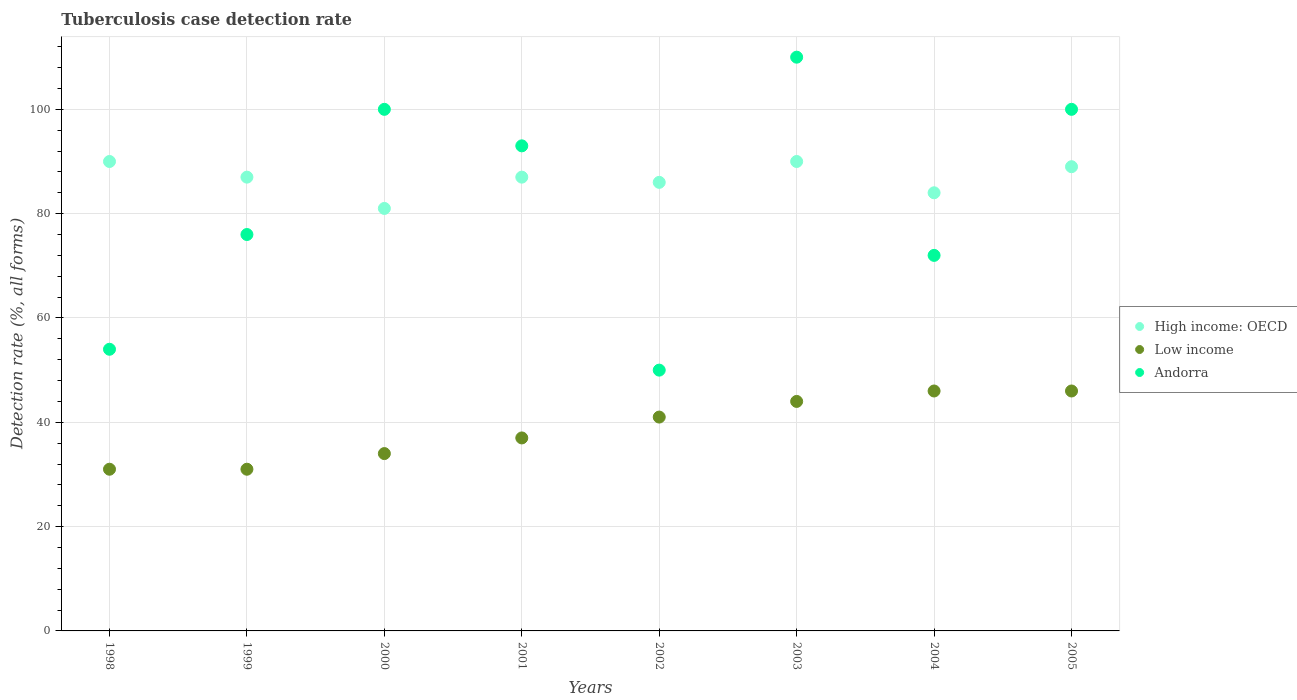How many different coloured dotlines are there?
Provide a succinct answer. 3. What is the tuberculosis case detection rate in in Low income in 2002?
Your response must be concise. 41. Across all years, what is the maximum tuberculosis case detection rate in in Low income?
Your response must be concise. 46. Across all years, what is the minimum tuberculosis case detection rate in in High income: OECD?
Offer a very short reply. 81. In which year was the tuberculosis case detection rate in in Andorra minimum?
Ensure brevity in your answer.  2002. What is the total tuberculosis case detection rate in in High income: OECD in the graph?
Make the answer very short. 694. What is the difference between the tuberculosis case detection rate in in Low income in 2002 and that in 2003?
Make the answer very short. -3. What is the difference between the tuberculosis case detection rate in in Low income in 2003 and the tuberculosis case detection rate in in High income: OECD in 2005?
Your answer should be very brief. -45. What is the average tuberculosis case detection rate in in Low income per year?
Make the answer very short. 38.75. In the year 2002, what is the difference between the tuberculosis case detection rate in in Andorra and tuberculosis case detection rate in in High income: OECD?
Ensure brevity in your answer.  -36. What is the ratio of the tuberculosis case detection rate in in Low income in 2002 to that in 2003?
Your answer should be very brief. 0.93. Is the tuberculosis case detection rate in in Andorra in 2001 less than that in 2005?
Ensure brevity in your answer.  Yes. Is the difference between the tuberculosis case detection rate in in Andorra in 1998 and 2002 greater than the difference between the tuberculosis case detection rate in in High income: OECD in 1998 and 2002?
Give a very brief answer. No. What is the difference between the highest and the second highest tuberculosis case detection rate in in Andorra?
Provide a short and direct response. 10. What is the difference between the highest and the lowest tuberculosis case detection rate in in High income: OECD?
Your answer should be very brief. 9. In how many years, is the tuberculosis case detection rate in in High income: OECD greater than the average tuberculosis case detection rate in in High income: OECD taken over all years?
Offer a very short reply. 5. Does the tuberculosis case detection rate in in High income: OECD monotonically increase over the years?
Ensure brevity in your answer.  No. Is the tuberculosis case detection rate in in Low income strictly greater than the tuberculosis case detection rate in in High income: OECD over the years?
Provide a short and direct response. No. How are the legend labels stacked?
Your answer should be very brief. Vertical. What is the title of the graph?
Provide a short and direct response. Tuberculosis case detection rate. What is the label or title of the X-axis?
Provide a short and direct response. Years. What is the label or title of the Y-axis?
Give a very brief answer. Detection rate (%, all forms). What is the Detection rate (%, all forms) of Andorra in 1998?
Your response must be concise. 54. What is the Detection rate (%, all forms) in High income: OECD in 1999?
Provide a short and direct response. 87. What is the Detection rate (%, all forms) in Low income in 1999?
Provide a succinct answer. 31. What is the Detection rate (%, all forms) of Andorra in 1999?
Your answer should be compact. 76. What is the Detection rate (%, all forms) of Low income in 2000?
Provide a succinct answer. 34. What is the Detection rate (%, all forms) of Andorra in 2000?
Give a very brief answer. 100. What is the Detection rate (%, all forms) in High income: OECD in 2001?
Provide a succinct answer. 87. What is the Detection rate (%, all forms) in Low income in 2001?
Your answer should be compact. 37. What is the Detection rate (%, all forms) in Andorra in 2001?
Offer a very short reply. 93. What is the Detection rate (%, all forms) in Low income in 2002?
Provide a succinct answer. 41. What is the Detection rate (%, all forms) in Low income in 2003?
Ensure brevity in your answer.  44. What is the Detection rate (%, all forms) of Andorra in 2003?
Ensure brevity in your answer.  110. What is the Detection rate (%, all forms) in High income: OECD in 2004?
Ensure brevity in your answer.  84. What is the Detection rate (%, all forms) of Low income in 2004?
Provide a short and direct response. 46. What is the Detection rate (%, all forms) of Andorra in 2004?
Make the answer very short. 72. What is the Detection rate (%, all forms) in High income: OECD in 2005?
Your response must be concise. 89. Across all years, what is the maximum Detection rate (%, all forms) in Low income?
Your response must be concise. 46. Across all years, what is the maximum Detection rate (%, all forms) in Andorra?
Make the answer very short. 110. Across all years, what is the minimum Detection rate (%, all forms) of Andorra?
Provide a succinct answer. 50. What is the total Detection rate (%, all forms) of High income: OECD in the graph?
Your answer should be very brief. 694. What is the total Detection rate (%, all forms) in Low income in the graph?
Make the answer very short. 310. What is the total Detection rate (%, all forms) of Andorra in the graph?
Your answer should be compact. 655. What is the difference between the Detection rate (%, all forms) of High income: OECD in 1998 and that in 1999?
Provide a short and direct response. 3. What is the difference between the Detection rate (%, all forms) of Low income in 1998 and that in 1999?
Offer a terse response. 0. What is the difference between the Detection rate (%, all forms) of Andorra in 1998 and that in 1999?
Make the answer very short. -22. What is the difference between the Detection rate (%, all forms) in High income: OECD in 1998 and that in 2000?
Your answer should be compact. 9. What is the difference between the Detection rate (%, all forms) of Andorra in 1998 and that in 2000?
Make the answer very short. -46. What is the difference between the Detection rate (%, all forms) in Low income in 1998 and that in 2001?
Provide a short and direct response. -6. What is the difference between the Detection rate (%, all forms) in Andorra in 1998 and that in 2001?
Make the answer very short. -39. What is the difference between the Detection rate (%, all forms) in Andorra in 1998 and that in 2002?
Your answer should be very brief. 4. What is the difference between the Detection rate (%, all forms) of High income: OECD in 1998 and that in 2003?
Give a very brief answer. 0. What is the difference between the Detection rate (%, all forms) in Andorra in 1998 and that in 2003?
Make the answer very short. -56. What is the difference between the Detection rate (%, all forms) in Low income in 1998 and that in 2004?
Ensure brevity in your answer.  -15. What is the difference between the Detection rate (%, all forms) of High income: OECD in 1998 and that in 2005?
Provide a succinct answer. 1. What is the difference between the Detection rate (%, all forms) of Andorra in 1998 and that in 2005?
Offer a very short reply. -46. What is the difference between the Detection rate (%, all forms) of Low income in 1999 and that in 2000?
Your response must be concise. -3. What is the difference between the Detection rate (%, all forms) in Andorra in 1999 and that in 2000?
Offer a terse response. -24. What is the difference between the Detection rate (%, all forms) of High income: OECD in 1999 and that in 2001?
Make the answer very short. 0. What is the difference between the Detection rate (%, all forms) in High income: OECD in 1999 and that in 2002?
Make the answer very short. 1. What is the difference between the Detection rate (%, all forms) of Low income in 1999 and that in 2002?
Provide a succinct answer. -10. What is the difference between the Detection rate (%, all forms) in High income: OECD in 1999 and that in 2003?
Provide a succinct answer. -3. What is the difference between the Detection rate (%, all forms) of Andorra in 1999 and that in 2003?
Ensure brevity in your answer.  -34. What is the difference between the Detection rate (%, all forms) of Andorra in 1999 and that in 2004?
Provide a short and direct response. 4. What is the difference between the Detection rate (%, all forms) of Low income in 1999 and that in 2005?
Your answer should be compact. -15. What is the difference between the Detection rate (%, all forms) in Andorra in 1999 and that in 2005?
Offer a terse response. -24. What is the difference between the Detection rate (%, all forms) of Low income in 2000 and that in 2001?
Provide a succinct answer. -3. What is the difference between the Detection rate (%, all forms) of Low income in 2000 and that in 2002?
Your response must be concise. -7. What is the difference between the Detection rate (%, all forms) of Andorra in 2000 and that in 2002?
Make the answer very short. 50. What is the difference between the Detection rate (%, all forms) of High income: OECD in 2000 and that in 2004?
Ensure brevity in your answer.  -3. What is the difference between the Detection rate (%, all forms) of Low income in 2000 and that in 2004?
Your answer should be compact. -12. What is the difference between the Detection rate (%, all forms) in High income: OECD in 2000 and that in 2005?
Your response must be concise. -8. What is the difference between the Detection rate (%, all forms) in Low income in 2001 and that in 2002?
Provide a short and direct response. -4. What is the difference between the Detection rate (%, all forms) of High income: OECD in 2001 and that in 2003?
Your response must be concise. -3. What is the difference between the Detection rate (%, all forms) of High income: OECD in 2001 and that in 2004?
Your answer should be very brief. 3. What is the difference between the Detection rate (%, all forms) of Low income in 2001 and that in 2004?
Provide a short and direct response. -9. What is the difference between the Detection rate (%, all forms) in Low income in 2001 and that in 2005?
Make the answer very short. -9. What is the difference between the Detection rate (%, all forms) in High income: OECD in 2002 and that in 2003?
Make the answer very short. -4. What is the difference between the Detection rate (%, all forms) in Low income in 2002 and that in 2003?
Offer a very short reply. -3. What is the difference between the Detection rate (%, all forms) in Andorra in 2002 and that in 2003?
Make the answer very short. -60. What is the difference between the Detection rate (%, all forms) in Low income in 2002 and that in 2004?
Keep it short and to the point. -5. What is the difference between the Detection rate (%, all forms) of Low income in 2002 and that in 2005?
Give a very brief answer. -5. What is the difference between the Detection rate (%, all forms) of High income: OECD in 2003 and that in 2004?
Give a very brief answer. 6. What is the difference between the Detection rate (%, all forms) in Low income in 2003 and that in 2004?
Your response must be concise. -2. What is the difference between the Detection rate (%, all forms) in Andorra in 2003 and that in 2004?
Make the answer very short. 38. What is the difference between the Detection rate (%, all forms) of High income: OECD in 2003 and that in 2005?
Your answer should be compact. 1. What is the difference between the Detection rate (%, all forms) in Low income in 2003 and that in 2005?
Make the answer very short. -2. What is the difference between the Detection rate (%, all forms) in Andorra in 2003 and that in 2005?
Your response must be concise. 10. What is the difference between the Detection rate (%, all forms) of Low income in 2004 and that in 2005?
Give a very brief answer. 0. What is the difference between the Detection rate (%, all forms) in Andorra in 2004 and that in 2005?
Give a very brief answer. -28. What is the difference between the Detection rate (%, all forms) of Low income in 1998 and the Detection rate (%, all forms) of Andorra in 1999?
Give a very brief answer. -45. What is the difference between the Detection rate (%, all forms) of High income: OECD in 1998 and the Detection rate (%, all forms) of Low income in 2000?
Keep it short and to the point. 56. What is the difference between the Detection rate (%, all forms) of High income: OECD in 1998 and the Detection rate (%, all forms) of Andorra in 2000?
Ensure brevity in your answer.  -10. What is the difference between the Detection rate (%, all forms) in Low income in 1998 and the Detection rate (%, all forms) in Andorra in 2000?
Your response must be concise. -69. What is the difference between the Detection rate (%, all forms) in High income: OECD in 1998 and the Detection rate (%, all forms) in Low income in 2001?
Offer a very short reply. 53. What is the difference between the Detection rate (%, all forms) in Low income in 1998 and the Detection rate (%, all forms) in Andorra in 2001?
Your answer should be compact. -62. What is the difference between the Detection rate (%, all forms) in High income: OECD in 1998 and the Detection rate (%, all forms) in Low income in 2002?
Keep it short and to the point. 49. What is the difference between the Detection rate (%, all forms) in High income: OECD in 1998 and the Detection rate (%, all forms) in Andorra in 2002?
Your response must be concise. 40. What is the difference between the Detection rate (%, all forms) in Low income in 1998 and the Detection rate (%, all forms) in Andorra in 2002?
Offer a very short reply. -19. What is the difference between the Detection rate (%, all forms) in High income: OECD in 1998 and the Detection rate (%, all forms) in Low income in 2003?
Ensure brevity in your answer.  46. What is the difference between the Detection rate (%, all forms) in High income: OECD in 1998 and the Detection rate (%, all forms) in Andorra in 2003?
Provide a short and direct response. -20. What is the difference between the Detection rate (%, all forms) in Low income in 1998 and the Detection rate (%, all forms) in Andorra in 2003?
Give a very brief answer. -79. What is the difference between the Detection rate (%, all forms) of Low income in 1998 and the Detection rate (%, all forms) of Andorra in 2004?
Offer a very short reply. -41. What is the difference between the Detection rate (%, all forms) in Low income in 1998 and the Detection rate (%, all forms) in Andorra in 2005?
Offer a terse response. -69. What is the difference between the Detection rate (%, all forms) in High income: OECD in 1999 and the Detection rate (%, all forms) in Andorra in 2000?
Make the answer very short. -13. What is the difference between the Detection rate (%, all forms) in Low income in 1999 and the Detection rate (%, all forms) in Andorra in 2000?
Keep it short and to the point. -69. What is the difference between the Detection rate (%, all forms) of Low income in 1999 and the Detection rate (%, all forms) of Andorra in 2001?
Your answer should be compact. -62. What is the difference between the Detection rate (%, all forms) of High income: OECD in 1999 and the Detection rate (%, all forms) of Low income in 2002?
Provide a short and direct response. 46. What is the difference between the Detection rate (%, all forms) of High income: OECD in 1999 and the Detection rate (%, all forms) of Andorra in 2002?
Offer a terse response. 37. What is the difference between the Detection rate (%, all forms) in High income: OECD in 1999 and the Detection rate (%, all forms) in Low income in 2003?
Your response must be concise. 43. What is the difference between the Detection rate (%, all forms) of High income: OECD in 1999 and the Detection rate (%, all forms) of Andorra in 2003?
Make the answer very short. -23. What is the difference between the Detection rate (%, all forms) in Low income in 1999 and the Detection rate (%, all forms) in Andorra in 2003?
Your answer should be very brief. -79. What is the difference between the Detection rate (%, all forms) of High income: OECD in 1999 and the Detection rate (%, all forms) of Low income in 2004?
Keep it short and to the point. 41. What is the difference between the Detection rate (%, all forms) in High income: OECD in 1999 and the Detection rate (%, all forms) in Andorra in 2004?
Keep it short and to the point. 15. What is the difference between the Detection rate (%, all forms) in Low income in 1999 and the Detection rate (%, all forms) in Andorra in 2004?
Keep it short and to the point. -41. What is the difference between the Detection rate (%, all forms) of High income: OECD in 1999 and the Detection rate (%, all forms) of Low income in 2005?
Your response must be concise. 41. What is the difference between the Detection rate (%, all forms) in High income: OECD in 1999 and the Detection rate (%, all forms) in Andorra in 2005?
Ensure brevity in your answer.  -13. What is the difference between the Detection rate (%, all forms) of Low income in 1999 and the Detection rate (%, all forms) of Andorra in 2005?
Offer a very short reply. -69. What is the difference between the Detection rate (%, all forms) in High income: OECD in 2000 and the Detection rate (%, all forms) in Andorra in 2001?
Provide a short and direct response. -12. What is the difference between the Detection rate (%, all forms) of Low income in 2000 and the Detection rate (%, all forms) of Andorra in 2001?
Keep it short and to the point. -59. What is the difference between the Detection rate (%, all forms) of High income: OECD in 2000 and the Detection rate (%, all forms) of Andorra in 2002?
Keep it short and to the point. 31. What is the difference between the Detection rate (%, all forms) in Low income in 2000 and the Detection rate (%, all forms) in Andorra in 2002?
Provide a short and direct response. -16. What is the difference between the Detection rate (%, all forms) of Low income in 2000 and the Detection rate (%, all forms) of Andorra in 2003?
Offer a terse response. -76. What is the difference between the Detection rate (%, all forms) of Low income in 2000 and the Detection rate (%, all forms) of Andorra in 2004?
Keep it short and to the point. -38. What is the difference between the Detection rate (%, all forms) of High income: OECD in 2000 and the Detection rate (%, all forms) of Andorra in 2005?
Ensure brevity in your answer.  -19. What is the difference between the Detection rate (%, all forms) in Low income in 2000 and the Detection rate (%, all forms) in Andorra in 2005?
Provide a succinct answer. -66. What is the difference between the Detection rate (%, all forms) in High income: OECD in 2001 and the Detection rate (%, all forms) in Andorra in 2002?
Ensure brevity in your answer.  37. What is the difference between the Detection rate (%, all forms) of Low income in 2001 and the Detection rate (%, all forms) of Andorra in 2002?
Your response must be concise. -13. What is the difference between the Detection rate (%, all forms) in High income: OECD in 2001 and the Detection rate (%, all forms) in Low income in 2003?
Your answer should be compact. 43. What is the difference between the Detection rate (%, all forms) in High income: OECD in 2001 and the Detection rate (%, all forms) in Andorra in 2003?
Give a very brief answer. -23. What is the difference between the Detection rate (%, all forms) in Low income in 2001 and the Detection rate (%, all forms) in Andorra in 2003?
Make the answer very short. -73. What is the difference between the Detection rate (%, all forms) of High income: OECD in 2001 and the Detection rate (%, all forms) of Andorra in 2004?
Your response must be concise. 15. What is the difference between the Detection rate (%, all forms) in Low income in 2001 and the Detection rate (%, all forms) in Andorra in 2004?
Keep it short and to the point. -35. What is the difference between the Detection rate (%, all forms) in High income: OECD in 2001 and the Detection rate (%, all forms) in Low income in 2005?
Give a very brief answer. 41. What is the difference between the Detection rate (%, all forms) of Low income in 2001 and the Detection rate (%, all forms) of Andorra in 2005?
Offer a terse response. -63. What is the difference between the Detection rate (%, all forms) of High income: OECD in 2002 and the Detection rate (%, all forms) of Low income in 2003?
Your answer should be compact. 42. What is the difference between the Detection rate (%, all forms) of High income: OECD in 2002 and the Detection rate (%, all forms) of Andorra in 2003?
Your response must be concise. -24. What is the difference between the Detection rate (%, all forms) of Low income in 2002 and the Detection rate (%, all forms) of Andorra in 2003?
Offer a terse response. -69. What is the difference between the Detection rate (%, all forms) in High income: OECD in 2002 and the Detection rate (%, all forms) in Andorra in 2004?
Offer a terse response. 14. What is the difference between the Detection rate (%, all forms) of Low income in 2002 and the Detection rate (%, all forms) of Andorra in 2004?
Provide a succinct answer. -31. What is the difference between the Detection rate (%, all forms) in High income: OECD in 2002 and the Detection rate (%, all forms) in Low income in 2005?
Offer a terse response. 40. What is the difference between the Detection rate (%, all forms) of Low income in 2002 and the Detection rate (%, all forms) of Andorra in 2005?
Provide a short and direct response. -59. What is the difference between the Detection rate (%, all forms) in High income: OECD in 2003 and the Detection rate (%, all forms) in Low income in 2004?
Provide a succinct answer. 44. What is the difference between the Detection rate (%, all forms) in Low income in 2003 and the Detection rate (%, all forms) in Andorra in 2005?
Keep it short and to the point. -56. What is the difference between the Detection rate (%, all forms) in High income: OECD in 2004 and the Detection rate (%, all forms) in Low income in 2005?
Make the answer very short. 38. What is the difference between the Detection rate (%, all forms) of High income: OECD in 2004 and the Detection rate (%, all forms) of Andorra in 2005?
Offer a very short reply. -16. What is the difference between the Detection rate (%, all forms) in Low income in 2004 and the Detection rate (%, all forms) in Andorra in 2005?
Your response must be concise. -54. What is the average Detection rate (%, all forms) in High income: OECD per year?
Your response must be concise. 86.75. What is the average Detection rate (%, all forms) in Low income per year?
Your response must be concise. 38.75. What is the average Detection rate (%, all forms) of Andorra per year?
Your answer should be compact. 81.88. In the year 1998, what is the difference between the Detection rate (%, all forms) of High income: OECD and Detection rate (%, all forms) of Low income?
Ensure brevity in your answer.  59. In the year 1998, what is the difference between the Detection rate (%, all forms) of Low income and Detection rate (%, all forms) of Andorra?
Provide a short and direct response. -23. In the year 1999, what is the difference between the Detection rate (%, all forms) of Low income and Detection rate (%, all forms) of Andorra?
Your answer should be compact. -45. In the year 2000, what is the difference between the Detection rate (%, all forms) of High income: OECD and Detection rate (%, all forms) of Andorra?
Offer a terse response. -19. In the year 2000, what is the difference between the Detection rate (%, all forms) in Low income and Detection rate (%, all forms) in Andorra?
Provide a short and direct response. -66. In the year 2001, what is the difference between the Detection rate (%, all forms) in High income: OECD and Detection rate (%, all forms) in Low income?
Your answer should be very brief. 50. In the year 2001, what is the difference between the Detection rate (%, all forms) in Low income and Detection rate (%, all forms) in Andorra?
Provide a short and direct response. -56. In the year 2002, what is the difference between the Detection rate (%, all forms) in High income: OECD and Detection rate (%, all forms) in Andorra?
Keep it short and to the point. 36. In the year 2002, what is the difference between the Detection rate (%, all forms) of Low income and Detection rate (%, all forms) of Andorra?
Keep it short and to the point. -9. In the year 2003, what is the difference between the Detection rate (%, all forms) of High income: OECD and Detection rate (%, all forms) of Andorra?
Your response must be concise. -20. In the year 2003, what is the difference between the Detection rate (%, all forms) in Low income and Detection rate (%, all forms) in Andorra?
Provide a succinct answer. -66. In the year 2004, what is the difference between the Detection rate (%, all forms) of Low income and Detection rate (%, all forms) of Andorra?
Keep it short and to the point. -26. In the year 2005, what is the difference between the Detection rate (%, all forms) in High income: OECD and Detection rate (%, all forms) in Andorra?
Give a very brief answer. -11. In the year 2005, what is the difference between the Detection rate (%, all forms) in Low income and Detection rate (%, all forms) in Andorra?
Give a very brief answer. -54. What is the ratio of the Detection rate (%, all forms) in High income: OECD in 1998 to that in 1999?
Provide a short and direct response. 1.03. What is the ratio of the Detection rate (%, all forms) in Andorra in 1998 to that in 1999?
Keep it short and to the point. 0.71. What is the ratio of the Detection rate (%, all forms) in High income: OECD in 1998 to that in 2000?
Your answer should be compact. 1.11. What is the ratio of the Detection rate (%, all forms) in Low income in 1998 to that in 2000?
Ensure brevity in your answer.  0.91. What is the ratio of the Detection rate (%, all forms) of Andorra in 1998 to that in 2000?
Give a very brief answer. 0.54. What is the ratio of the Detection rate (%, all forms) in High income: OECD in 1998 to that in 2001?
Make the answer very short. 1.03. What is the ratio of the Detection rate (%, all forms) in Low income in 1998 to that in 2001?
Keep it short and to the point. 0.84. What is the ratio of the Detection rate (%, all forms) in Andorra in 1998 to that in 2001?
Your answer should be compact. 0.58. What is the ratio of the Detection rate (%, all forms) in High income: OECD in 1998 to that in 2002?
Provide a short and direct response. 1.05. What is the ratio of the Detection rate (%, all forms) in Low income in 1998 to that in 2002?
Your answer should be very brief. 0.76. What is the ratio of the Detection rate (%, all forms) of High income: OECD in 1998 to that in 2003?
Offer a very short reply. 1. What is the ratio of the Detection rate (%, all forms) of Low income in 1998 to that in 2003?
Your response must be concise. 0.7. What is the ratio of the Detection rate (%, all forms) in Andorra in 1998 to that in 2003?
Your answer should be very brief. 0.49. What is the ratio of the Detection rate (%, all forms) in High income: OECD in 1998 to that in 2004?
Provide a short and direct response. 1.07. What is the ratio of the Detection rate (%, all forms) of Low income in 1998 to that in 2004?
Make the answer very short. 0.67. What is the ratio of the Detection rate (%, all forms) in High income: OECD in 1998 to that in 2005?
Your response must be concise. 1.01. What is the ratio of the Detection rate (%, all forms) of Low income in 1998 to that in 2005?
Your answer should be compact. 0.67. What is the ratio of the Detection rate (%, all forms) of Andorra in 1998 to that in 2005?
Make the answer very short. 0.54. What is the ratio of the Detection rate (%, all forms) in High income: OECD in 1999 to that in 2000?
Ensure brevity in your answer.  1.07. What is the ratio of the Detection rate (%, all forms) of Low income in 1999 to that in 2000?
Provide a short and direct response. 0.91. What is the ratio of the Detection rate (%, all forms) of Andorra in 1999 to that in 2000?
Ensure brevity in your answer.  0.76. What is the ratio of the Detection rate (%, all forms) of Low income in 1999 to that in 2001?
Offer a terse response. 0.84. What is the ratio of the Detection rate (%, all forms) in Andorra in 1999 to that in 2001?
Make the answer very short. 0.82. What is the ratio of the Detection rate (%, all forms) in High income: OECD in 1999 to that in 2002?
Offer a very short reply. 1.01. What is the ratio of the Detection rate (%, all forms) of Low income in 1999 to that in 2002?
Offer a very short reply. 0.76. What is the ratio of the Detection rate (%, all forms) of Andorra in 1999 to that in 2002?
Your response must be concise. 1.52. What is the ratio of the Detection rate (%, all forms) in High income: OECD in 1999 to that in 2003?
Your answer should be compact. 0.97. What is the ratio of the Detection rate (%, all forms) of Low income in 1999 to that in 2003?
Your response must be concise. 0.7. What is the ratio of the Detection rate (%, all forms) of Andorra in 1999 to that in 2003?
Make the answer very short. 0.69. What is the ratio of the Detection rate (%, all forms) in High income: OECD in 1999 to that in 2004?
Your answer should be compact. 1.04. What is the ratio of the Detection rate (%, all forms) of Low income in 1999 to that in 2004?
Ensure brevity in your answer.  0.67. What is the ratio of the Detection rate (%, all forms) of Andorra in 1999 to that in 2004?
Give a very brief answer. 1.06. What is the ratio of the Detection rate (%, all forms) in High income: OECD in 1999 to that in 2005?
Provide a succinct answer. 0.98. What is the ratio of the Detection rate (%, all forms) of Low income in 1999 to that in 2005?
Provide a short and direct response. 0.67. What is the ratio of the Detection rate (%, all forms) in Andorra in 1999 to that in 2005?
Keep it short and to the point. 0.76. What is the ratio of the Detection rate (%, all forms) in High income: OECD in 2000 to that in 2001?
Provide a short and direct response. 0.93. What is the ratio of the Detection rate (%, all forms) of Low income in 2000 to that in 2001?
Make the answer very short. 0.92. What is the ratio of the Detection rate (%, all forms) in Andorra in 2000 to that in 2001?
Provide a short and direct response. 1.08. What is the ratio of the Detection rate (%, all forms) of High income: OECD in 2000 to that in 2002?
Keep it short and to the point. 0.94. What is the ratio of the Detection rate (%, all forms) in Low income in 2000 to that in 2002?
Make the answer very short. 0.83. What is the ratio of the Detection rate (%, all forms) of Andorra in 2000 to that in 2002?
Offer a very short reply. 2. What is the ratio of the Detection rate (%, all forms) in Low income in 2000 to that in 2003?
Ensure brevity in your answer.  0.77. What is the ratio of the Detection rate (%, all forms) of Andorra in 2000 to that in 2003?
Your answer should be very brief. 0.91. What is the ratio of the Detection rate (%, all forms) in Low income in 2000 to that in 2004?
Provide a succinct answer. 0.74. What is the ratio of the Detection rate (%, all forms) in Andorra in 2000 to that in 2004?
Offer a terse response. 1.39. What is the ratio of the Detection rate (%, all forms) of High income: OECD in 2000 to that in 2005?
Make the answer very short. 0.91. What is the ratio of the Detection rate (%, all forms) in Low income in 2000 to that in 2005?
Give a very brief answer. 0.74. What is the ratio of the Detection rate (%, all forms) in Andorra in 2000 to that in 2005?
Offer a very short reply. 1. What is the ratio of the Detection rate (%, all forms) of High income: OECD in 2001 to that in 2002?
Provide a succinct answer. 1.01. What is the ratio of the Detection rate (%, all forms) of Low income in 2001 to that in 2002?
Your answer should be compact. 0.9. What is the ratio of the Detection rate (%, all forms) in Andorra in 2001 to that in 2002?
Give a very brief answer. 1.86. What is the ratio of the Detection rate (%, all forms) of High income: OECD in 2001 to that in 2003?
Your answer should be compact. 0.97. What is the ratio of the Detection rate (%, all forms) of Low income in 2001 to that in 2003?
Give a very brief answer. 0.84. What is the ratio of the Detection rate (%, all forms) in Andorra in 2001 to that in 2003?
Make the answer very short. 0.85. What is the ratio of the Detection rate (%, all forms) of High income: OECD in 2001 to that in 2004?
Your answer should be very brief. 1.04. What is the ratio of the Detection rate (%, all forms) of Low income in 2001 to that in 2004?
Offer a very short reply. 0.8. What is the ratio of the Detection rate (%, all forms) of Andorra in 2001 to that in 2004?
Offer a very short reply. 1.29. What is the ratio of the Detection rate (%, all forms) of High income: OECD in 2001 to that in 2005?
Your answer should be very brief. 0.98. What is the ratio of the Detection rate (%, all forms) of Low income in 2001 to that in 2005?
Give a very brief answer. 0.8. What is the ratio of the Detection rate (%, all forms) of High income: OECD in 2002 to that in 2003?
Give a very brief answer. 0.96. What is the ratio of the Detection rate (%, all forms) in Low income in 2002 to that in 2003?
Keep it short and to the point. 0.93. What is the ratio of the Detection rate (%, all forms) of Andorra in 2002 to that in 2003?
Your answer should be very brief. 0.45. What is the ratio of the Detection rate (%, all forms) of High income: OECD in 2002 to that in 2004?
Your answer should be very brief. 1.02. What is the ratio of the Detection rate (%, all forms) of Low income in 2002 to that in 2004?
Your response must be concise. 0.89. What is the ratio of the Detection rate (%, all forms) in Andorra in 2002 to that in 2004?
Your answer should be very brief. 0.69. What is the ratio of the Detection rate (%, all forms) of High income: OECD in 2002 to that in 2005?
Provide a short and direct response. 0.97. What is the ratio of the Detection rate (%, all forms) in Low income in 2002 to that in 2005?
Offer a terse response. 0.89. What is the ratio of the Detection rate (%, all forms) of High income: OECD in 2003 to that in 2004?
Make the answer very short. 1.07. What is the ratio of the Detection rate (%, all forms) of Low income in 2003 to that in 2004?
Your answer should be compact. 0.96. What is the ratio of the Detection rate (%, all forms) of Andorra in 2003 to that in 2004?
Your answer should be very brief. 1.53. What is the ratio of the Detection rate (%, all forms) of High income: OECD in 2003 to that in 2005?
Your response must be concise. 1.01. What is the ratio of the Detection rate (%, all forms) of Low income in 2003 to that in 2005?
Your answer should be very brief. 0.96. What is the ratio of the Detection rate (%, all forms) of Andorra in 2003 to that in 2005?
Ensure brevity in your answer.  1.1. What is the ratio of the Detection rate (%, all forms) in High income: OECD in 2004 to that in 2005?
Provide a succinct answer. 0.94. What is the ratio of the Detection rate (%, all forms) in Andorra in 2004 to that in 2005?
Ensure brevity in your answer.  0.72. What is the difference between the highest and the second highest Detection rate (%, all forms) of Low income?
Make the answer very short. 0. What is the difference between the highest and the second highest Detection rate (%, all forms) of Andorra?
Your response must be concise. 10. What is the difference between the highest and the lowest Detection rate (%, all forms) of Low income?
Make the answer very short. 15. What is the difference between the highest and the lowest Detection rate (%, all forms) in Andorra?
Provide a short and direct response. 60. 